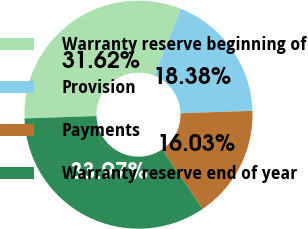<chart> <loc_0><loc_0><loc_500><loc_500><pie_chart><fcel>Warranty reserve beginning of<fcel>Provision<fcel>Payments<fcel>Warranty reserve end of year<nl><fcel>31.62%<fcel>18.38%<fcel>16.03%<fcel>33.97%<nl></chart> 